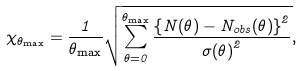<formula> <loc_0><loc_0><loc_500><loc_500>\chi _ { \theta _ { \max } } = \frac { 1 } { \theta _ { \max } } \sqrt { \sum _ { \theta = 0 } ^ { \theta _ { \mathrm { \max } } } \frac { \left \{ N ( \theta ) - N _ { o b s } ( \theta ) \right \} ^ { 2 } } { { \sigma ( \theta ) } ^ { 2 } } } ,</formula> 